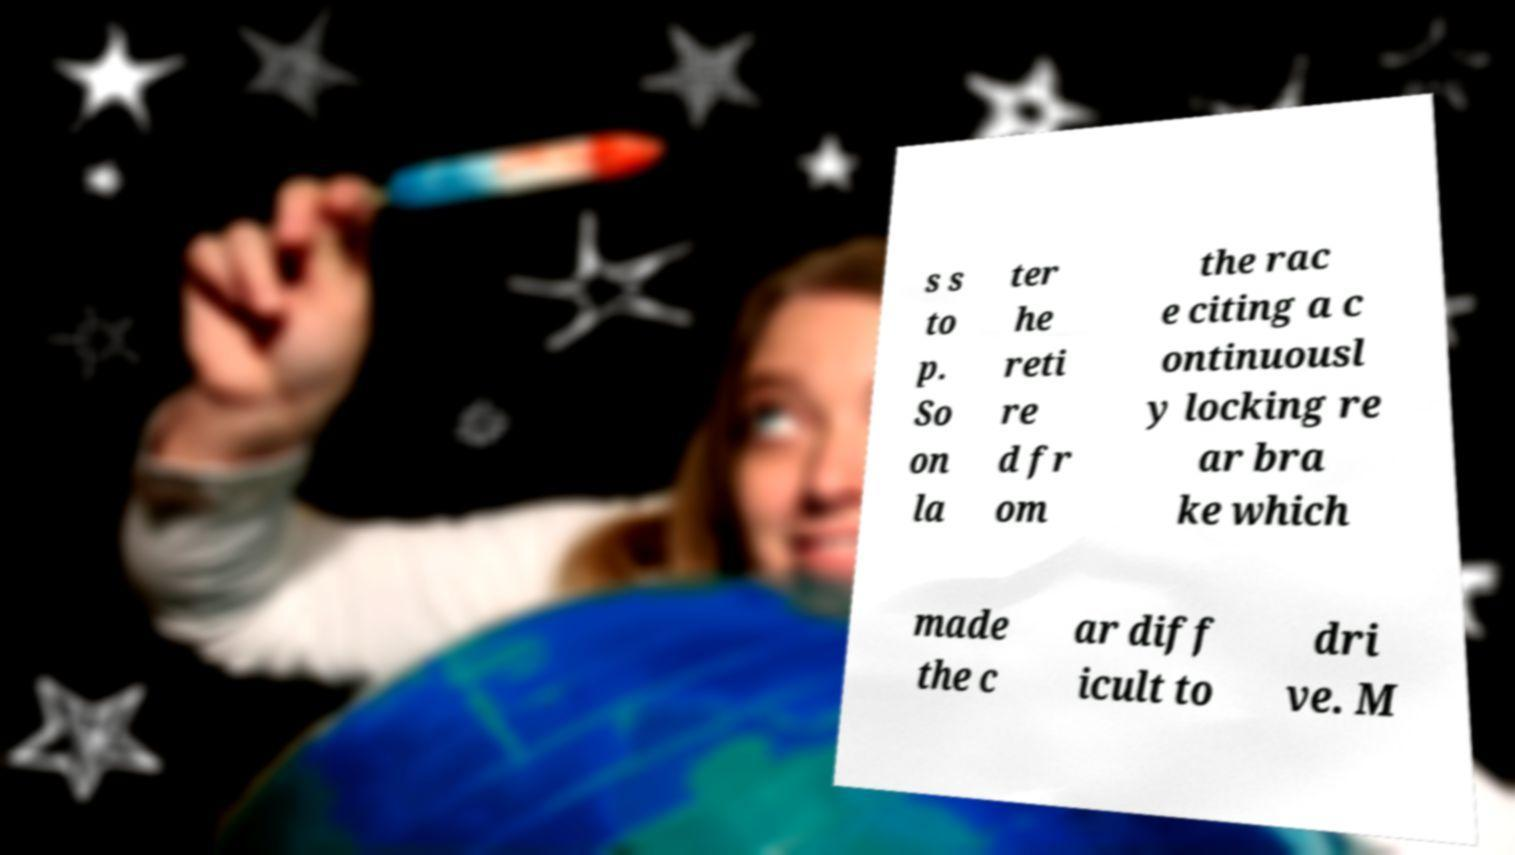Can you accurately transcribe the text from the provided image for me? s s to p. So on la ter he reti re d fr om the rac e citing a c ontinuousl y locking re ar bra ke which made the c ar diff icult to dri ve. M 